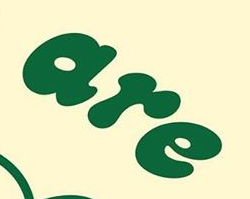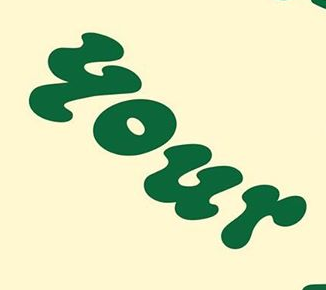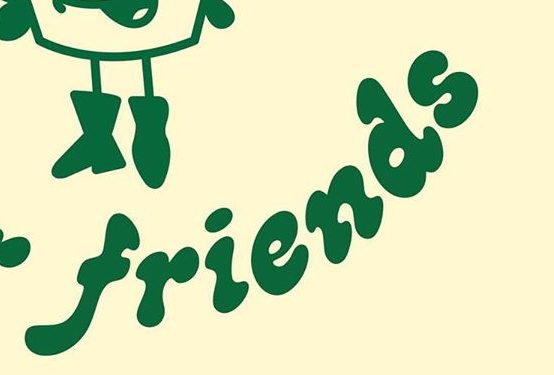Read the text from these images in sequence, separated by a semicolon. are; your; friends 